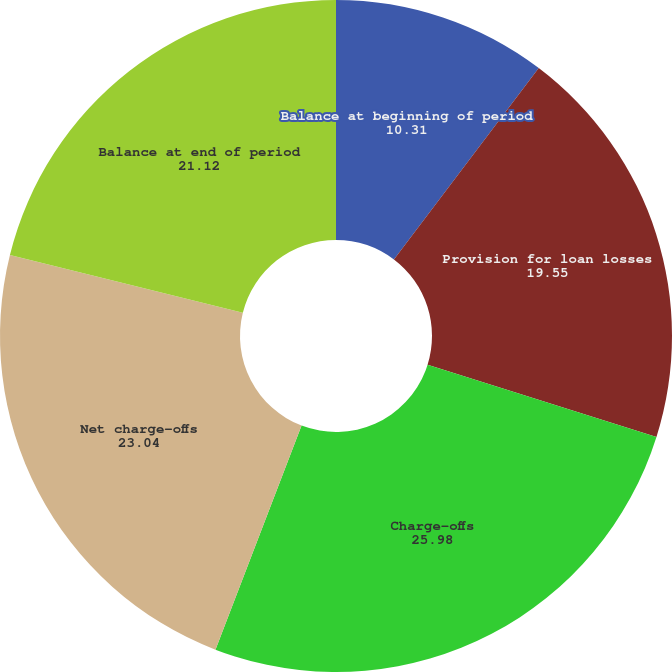Convert chart. <chart><loc_0><loc_0><loc_500><loc_500><pie_chart><fcel>Balance at beginning of period<fcel>Provision for loan losses<fcel>Charge-offs<fcel>Net charge-offs<fcel>Balance at end of period<nl><fcel>10.31%<fcel>19.55%<fcel>25.98%<fcel>23.04%<fcel>21.12%<nl></chart> 